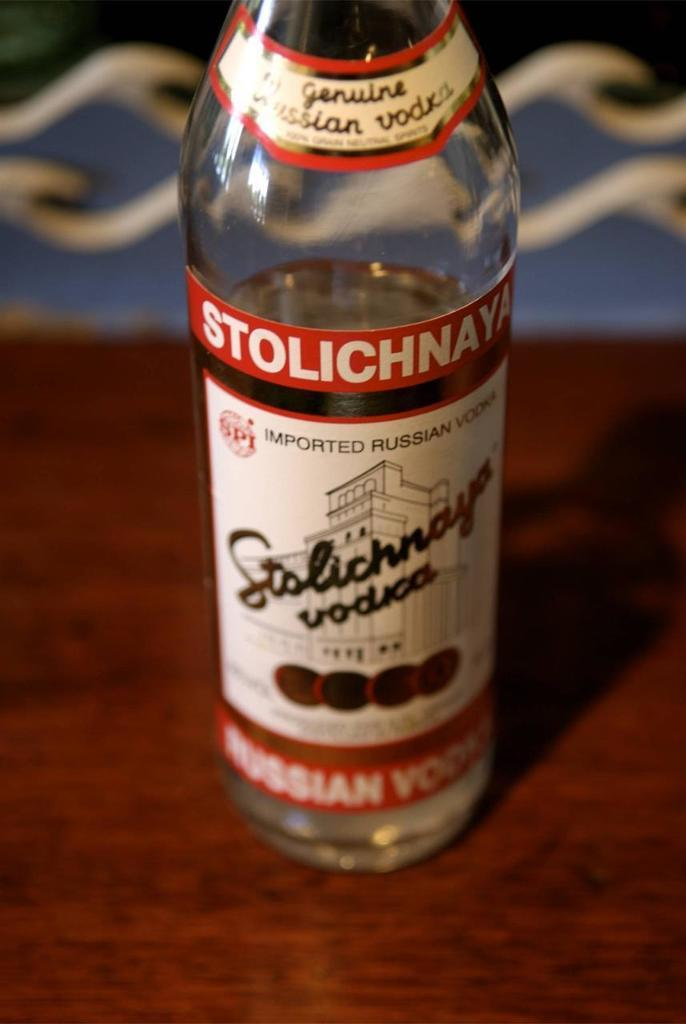<image>
Present a compact description of the photo's key features. A bottle of Stolichnaya Vodka is sitting on a table. 